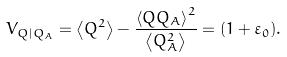<formula> <loc_0><loc_0><loc_500><loc_500>V _ { Q | Q _ { A } } = \left \langle { Q ^ { 2 } } \right \rangle - \frac { { \left \langle { Q Q _ { A } } \right \rangle ^ { 2 } } } { { \left \langle { Q _ { A } ^ { 2 } } \right \rangle } } = ( 1 + \varepsilon _ { 0 } ) .</formula> 